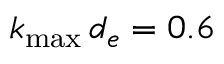Convert formula to latex. <formula><loc_0><loc_0><loc_500><loc_500>k _ { \max } \, d _ { e } = 0 . 6</formula> 